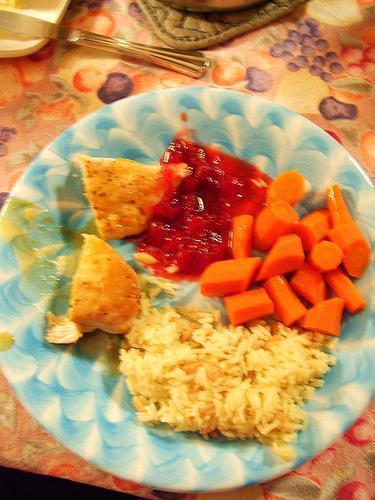How many plates are there?
Give a very brief answer. 1. 